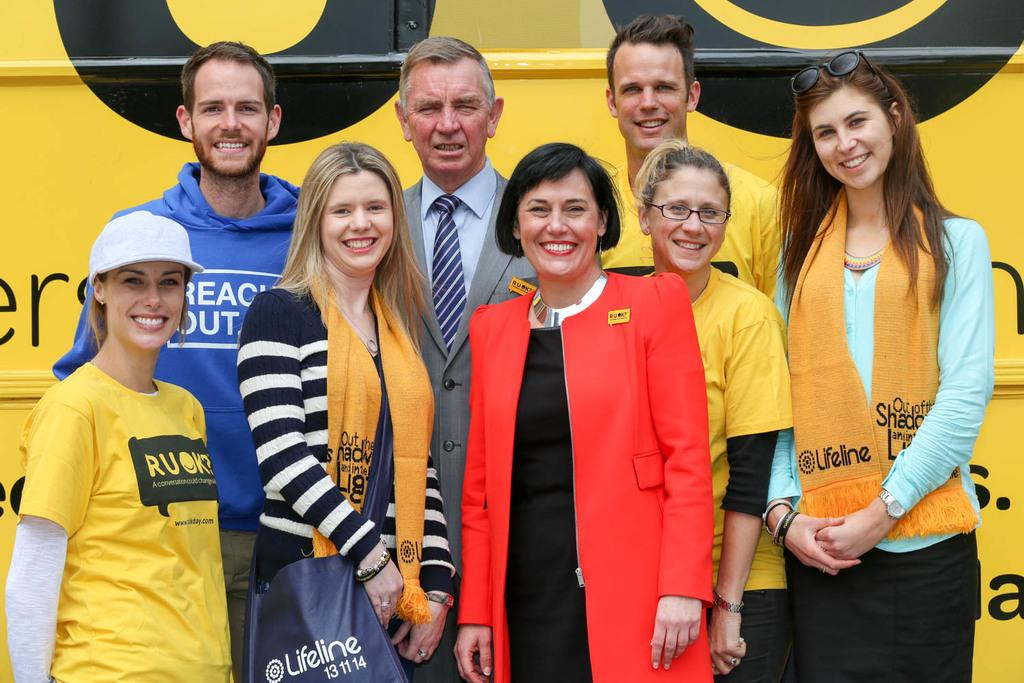<image>
Describe the image concisely. Lifeline is on the yellow scarves and blue bag. 